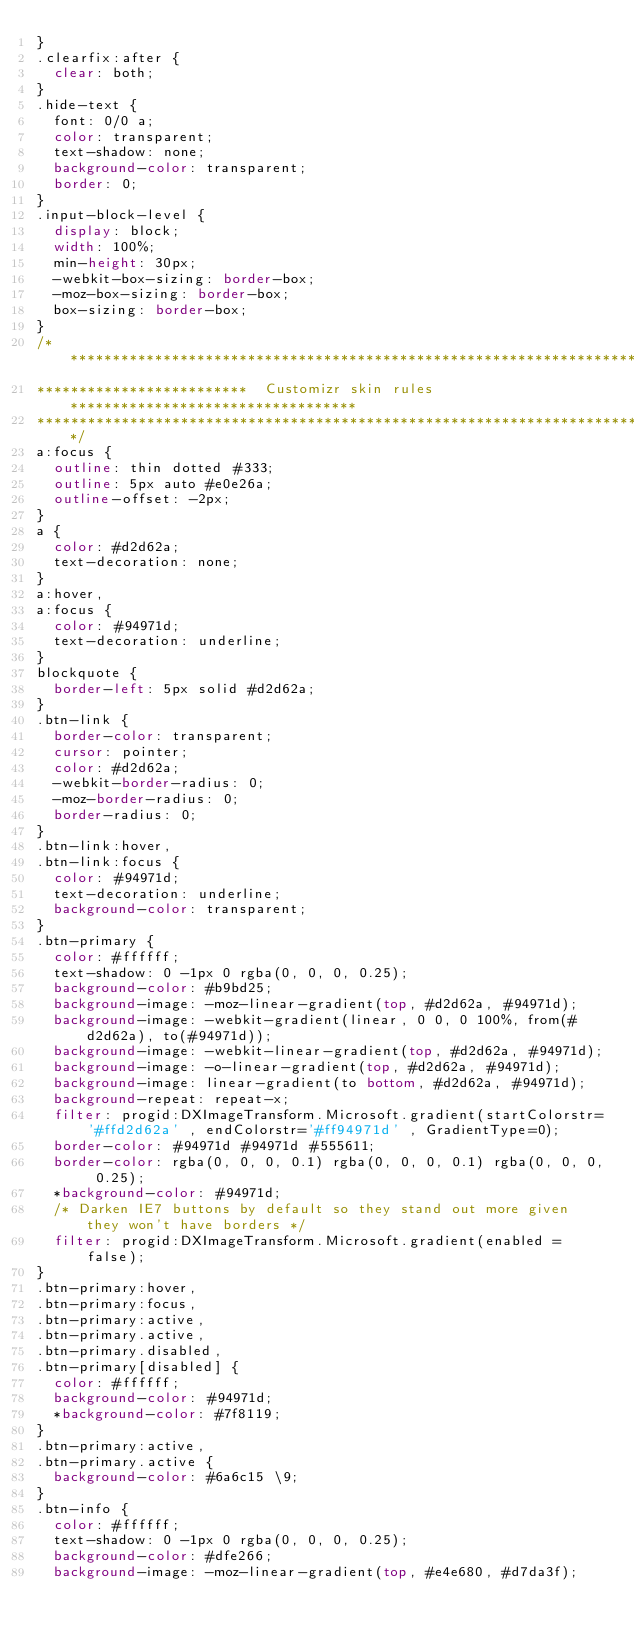Convert code to text. <code><loc_0><loc_0><loc_500><loc_500><_CSS_>}
.clearfix:after {
  clear: both;
}
.hide-text {
  font: 0/0 a;
  color: transparent;
  text-shadow: none;
  background-color: transparent;
  border: 0;
}
.input-block-level {
  display: block;
  width: 100%;
  min-height: 30px;
  -webkit-box-sizing: border-box;
  -moz-box-sizing: border-box;
  box-sizing: border-box;
}
/*********************************************************************************
*************************  Customizr skin rules **********************************
**********************************************************************************/
a:focus {
  outline: thin dotted #333;
  outline: 5px auto #e0e26a;
  outline-offset: -2px;
}
a {
  color: #d2d62a;
  text-decoration: none;
}
a:hover,
a:focus {
  color: #94971d;
  text-decoration: underline;
}
blockquote {
  border-left: 5px solid #d2d62a;
}
.btn-link {
  border-color: transparent;
  cursor: pointer;
  color: #d2d62a;
  -webkit-border-radius: 0;
  -moz-border-radius: 0;
  border-radius: 0;
}
.btn-link:hover,
.btn-link:focus {
  color: #94971d;
  text-decoration: underline;
  background-color: transparent;
}
.btn-primary {
  color: #ffffff;
  text-shadow: 0 -1px 0 rgba(0, 0, 0, 0.25);
  background-color: #b9bd25;
  background-image: -moz-linear-gradient(top, #d2d62a, #94971d);
  background-image: -webkit-gradient(linear, 0 0, 0 100%, from(#d2d62a), to(#94971d));
  background-image: -webkit-linear-gradient(top, #d2d62a, #94971d);
  background-image: -o-linear-gradient(top, #d2d62a, #94971d);
  background-image: linear-gradient(to bottom, #d2d62a, #94971d);
  background-repeat: repeat-x;
  filter: progid:DXImageTransform.Microsoft.gradient(startColorstr='#ffd2d62a' , endColorstr='#ff94971d' , GradientType=0);
  border-color: #94971d #94971d #555611;
  border-color: rgba(0, 0, 0, 0.1) rgba(0, 0, 0, 0.1) rgba(0, 0, 0, 0.25);
  *background-color: #94971d;
  /* Darken IE7 buttons by default so they stand out more given they won't have borders */
  filter: progid:DXImageTransform.Microsoft.gradient(enabled = false);
}
.btn-primary:hover,
.btn-primary:focus,
.btn-primary:active,
.btn-primary.active,
.btn-primary.disabled,
.btn-primary[disabled] {
  color: #ffffff;
  background-color: #94971d;
  *background-color: #7f8119;
}
.btn-primary:active,
.btn-primary.active {
  background-color: #6a6c15 \9;
}
.btn-info {
  color: #ffffff;
  text-shadow: 0 -1px 0 rgba(0, 0, 0, 0.25);
  background-color: #dfe266;
  background-image: -moz-linear-gradient(top, #e4e680, #d7da3f);</code> 